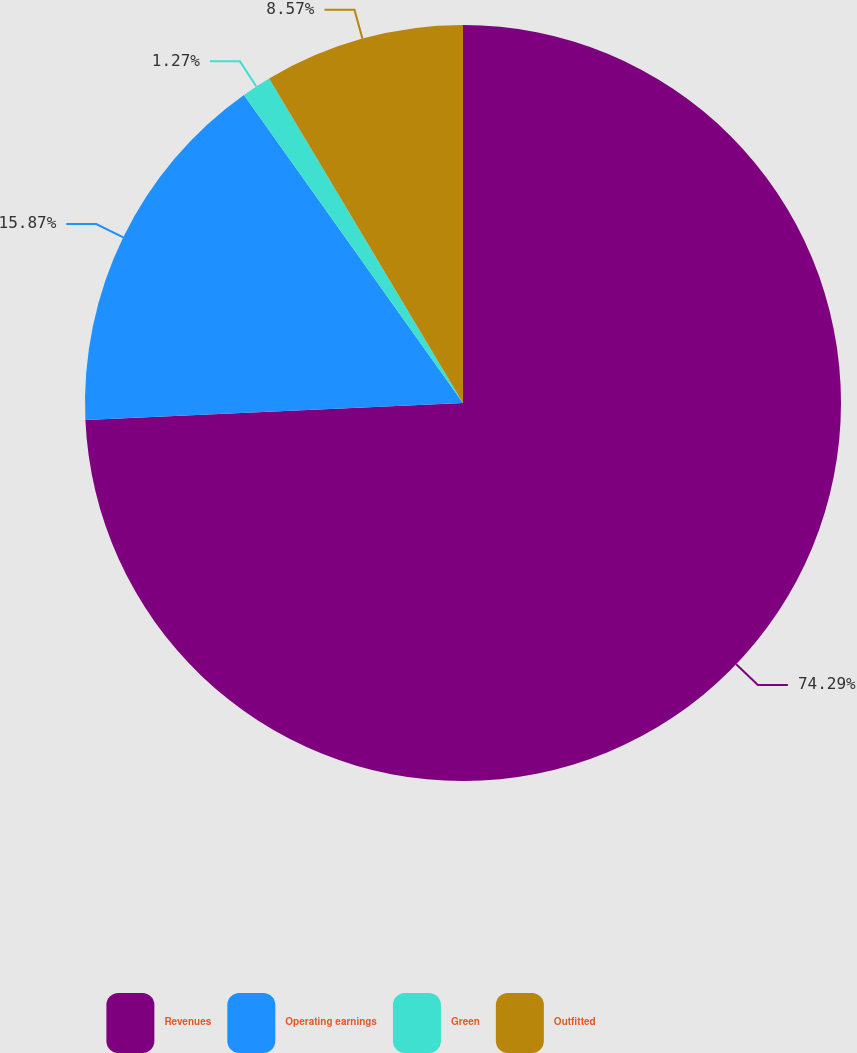<chart> <loc_0><loc_0><loc_500><loc_500><pie_chart><fcel>Revenues<fcel>Operating earnings<fcel>Green<fcel>Outfitted<nl><fcel>74.28%<fcel>15.87%<fcel>1.27%<fcel>8.57%<nl></chart> 